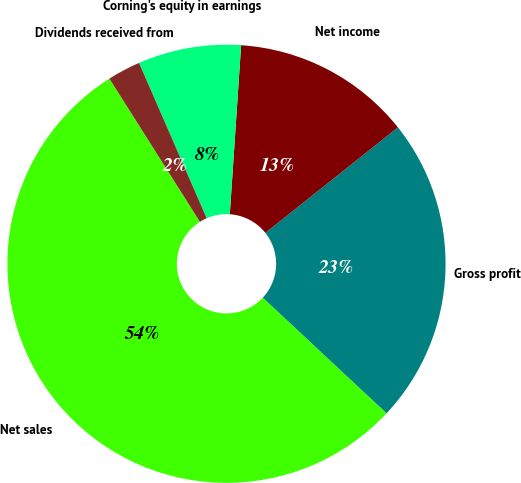Convert chart to OTSL. <chart><loc_0><loc_0><loc_500><loc_500><pie_chart><fcel>Net sales<fcel>Gross profit<fcel>Net income<fcel>Corning's equity in earnings<fcel>Dividends received from<nl><fcel>54.07%<fcel>22.65%<fcel>13.24%<fcel>7.6%<fcel>2.44%<nl></chart> 